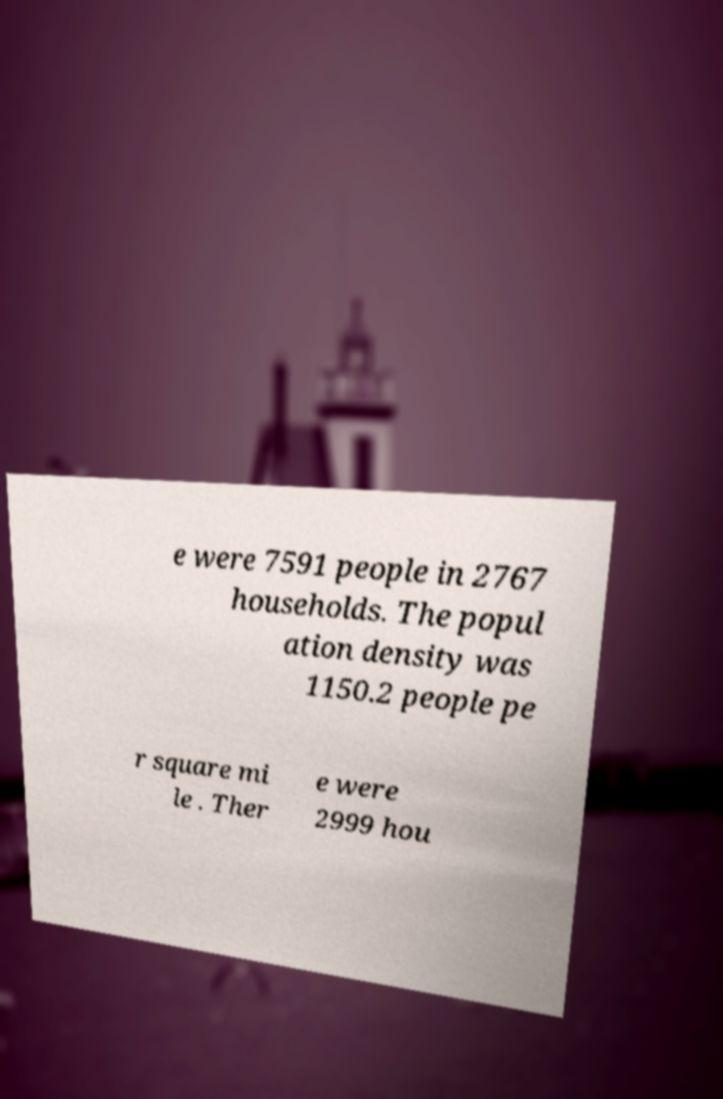There's text embedded in this image that I need extracted. Can you transcribe it verbatim? e were 7591 people in 2767 households. The popul ation density was 1150.2 people pe r square mi le . Ther e were 2999 hou 